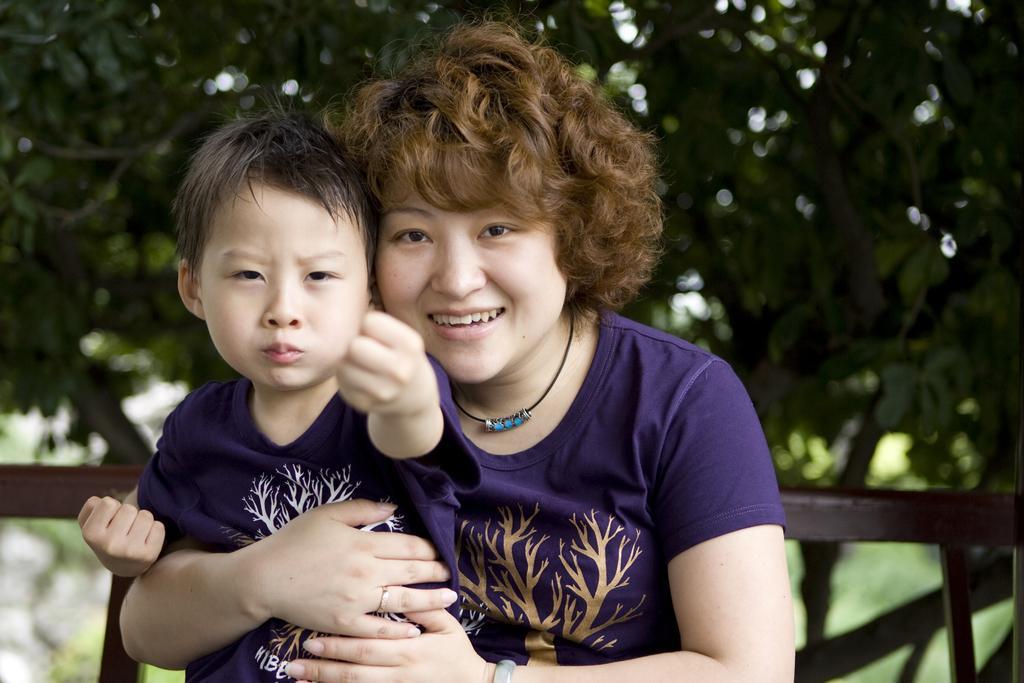Could you give a brief overview of what you see in this image? In this image we can see a woman holding child. In the background we can see wooden grill, trees and sky. 